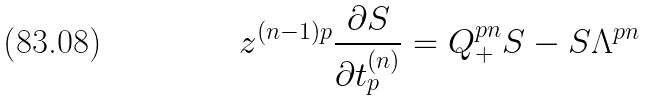<formula> <loc_0><loc_0><loc_500><loc_500>z ^ { ( n - 1 ) p } \frac { \partial S } { \partial t ^ { ( n ) } _ { p } } = Q _ { + } ^ { p n } S - S \Lambda ^ { p n }</formula> 